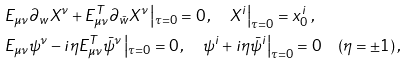<formula> <loc_0><loc_0><loc_500><loc_500>& E _ { \mu \nu } \partial _ { w } X ^ { \nu } + E _ { \mu \nu } ^ { T } \partial _ { \bar { w } } X ^ { \nu } \left | _ { \tau = 0 } = 0 \, , \quad X ^ { i } \right | _ { \tau = 0 } = x _ { 0 } ^ { i } \, , \\ & E _ { \mu \nu } \psi ^ { \nu } - i { \eta } E _ { \mu \nu } ^ { T } \bar { \psi } ^ { \nu } \left | _ { \tau = 0 } = 0 \, , \quad \psi ^ { i } + i \eta \bar { \psi } ^ { i } \right | _ { \tau = 0 } = 0 \quad ( \eta = \pm 1 ) \, ,</formula> 